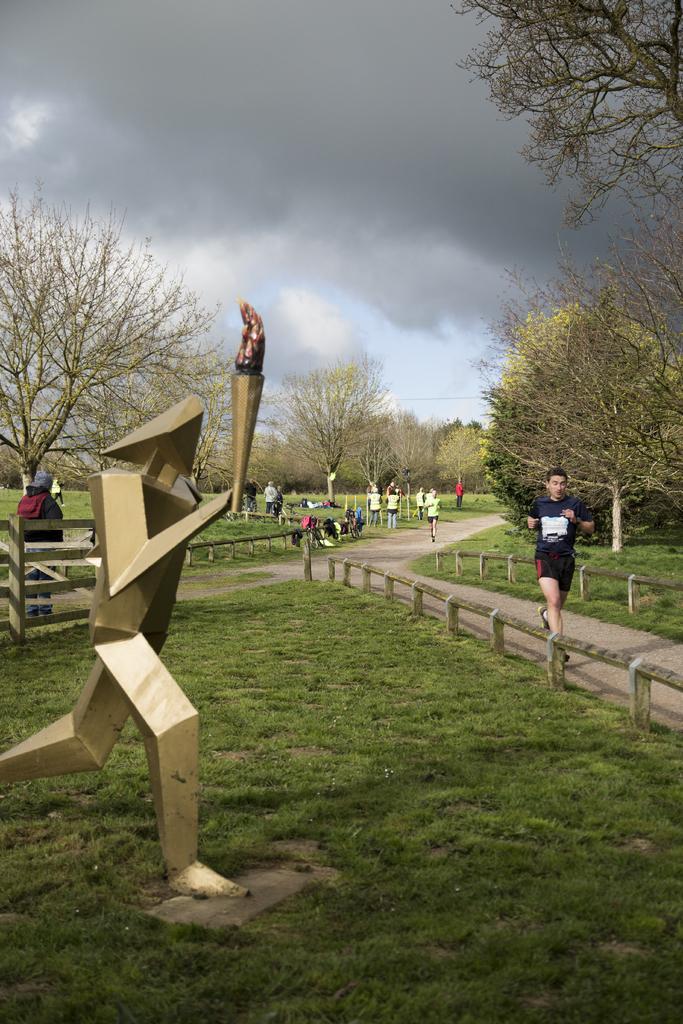Describe this image in one or two sentences. In this picture I can see trees and couple of them running and few are walking and a human standing and I can see grass on the ground and a blue cloudy sky and I can see architecture. 